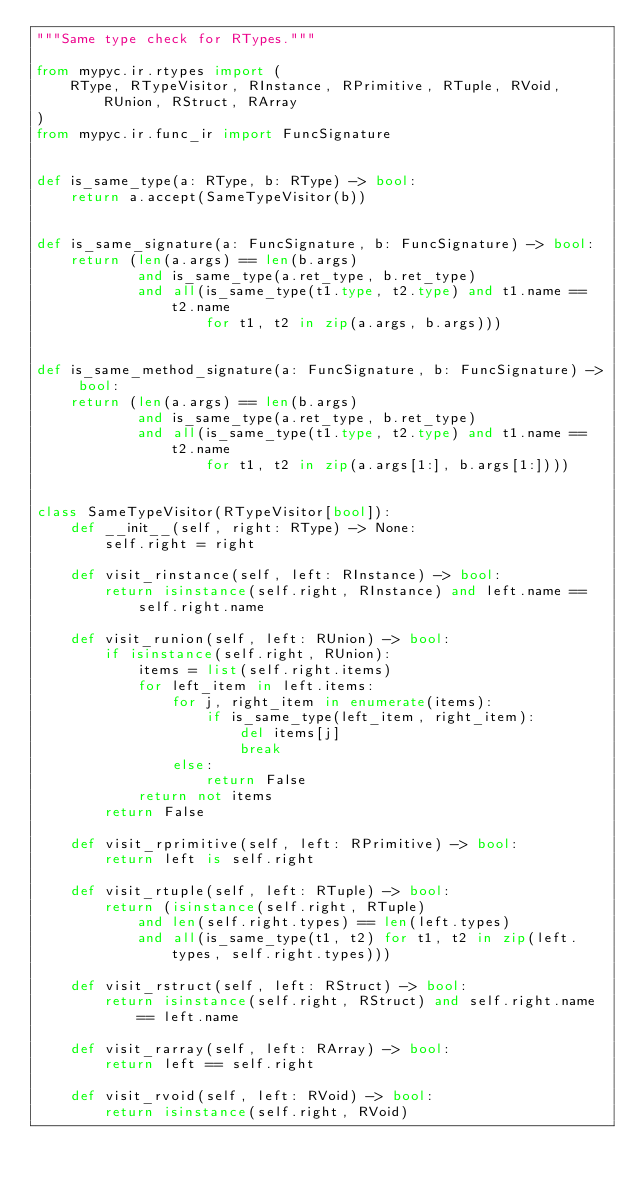Convert code to text. <code><loc_0><loc_0><loc_500><loc_500><_Python_>"""Same type check for RTypes."""

from mypyc.ir.rtypes import (
    RType, RTypeVisitor, RInstance, RPrimitive, RTuple, RVoid, RUnion, RStruct, RArray
)
from mypyc.ir.func_ir import FuncSignature


def is_same_type(a: RType, b: RType) -> bool:
    return a.accept(SameTypeVisitor(b))


def is_same_signature(a: FuncSignature, b: FuncSignature) -> bool:
    return (len(a.args) == len(b.args)
            and is_same_type(a.ret_type, b.ret_type)
            and all(is_same_type(t1.type, t2.type) and t1.name == t2.name
                    for t1, t2 in zip(a.args, b.args)))


def is_same_method_signature(a: FuncSignature, b: FuncSignature) -> bool:
    return (len(a.args) == len(b.args)
            and is_same_type(a.ret_type, b.ret_type)
            and all(is_same_type(t1.type, t2.type) and t1.name == t2.name
                    for t1, t2 in zip(a.args[1:], b.args[1:])))


class SameTypeVisitor(RTypeVisitor[bool]):
    def __init__(self, right: RType) -> None:
        self.right = right

    def visit_rinstance(self, left: RInstance) -> bool:
        return isinstance(self.right, RInstance) and left.name == self.right.name

    def visit_runion(self, left: RUnion) -> bool:
        if isinstance(self.right, RUnion):
            items = list(self.right.items)
            for left_item in left.items:
                for j, right_item in enumerate(items):
                    if is_same_type(left_item, right_item):
                        del items[j]
                        break
                else:
                    return False
            return not items
        return False

    def visit_rprimitive(self, left: RPrimitive) -> bool:
        return left is self.right

    def visit_rtuple(self, left: RTuple) -> bool:
        return (isinstance(self.right, RTuple)
            and len(self.right.types) == len(left.types)
            and all(is_same_type(t1, t2) for t1, t2 in zip(left.types, self.right.types)))

    def visit_rstruct(self, left: RStruct) -> bool:
        return isinstance(self.right, RStruct) and self.right.name == left.name

    def visit_rarray(self, left: RArray) -> bool:
        return left == self.right

    def visit_rvoid(self, left: RVoid) -> bool:
        return isinstance(self.right, RVoid)
</code> 